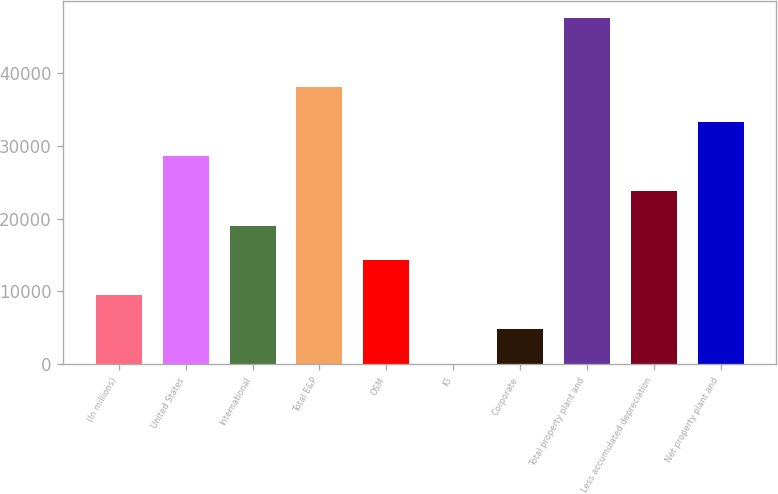<chart> <loc_0><loc_0><loc_500><loc_500><bar_chart><fcel>(In millions)<fcel>United States<fcel>International<fcel>Total E&P<fcel>OSM<fcel>IG<fcel>Corporate<fcel>Total property plant and<fcel>Less accumulated depreciation<fcel>Net property plant and<nl><fcel>9538<fcel>28538<fcel>19038<fcel>38038<fcel>14288<fcel>38<fcel>4788<fcel>47538<fcel>23788<fcel>33288<nl></chart> 